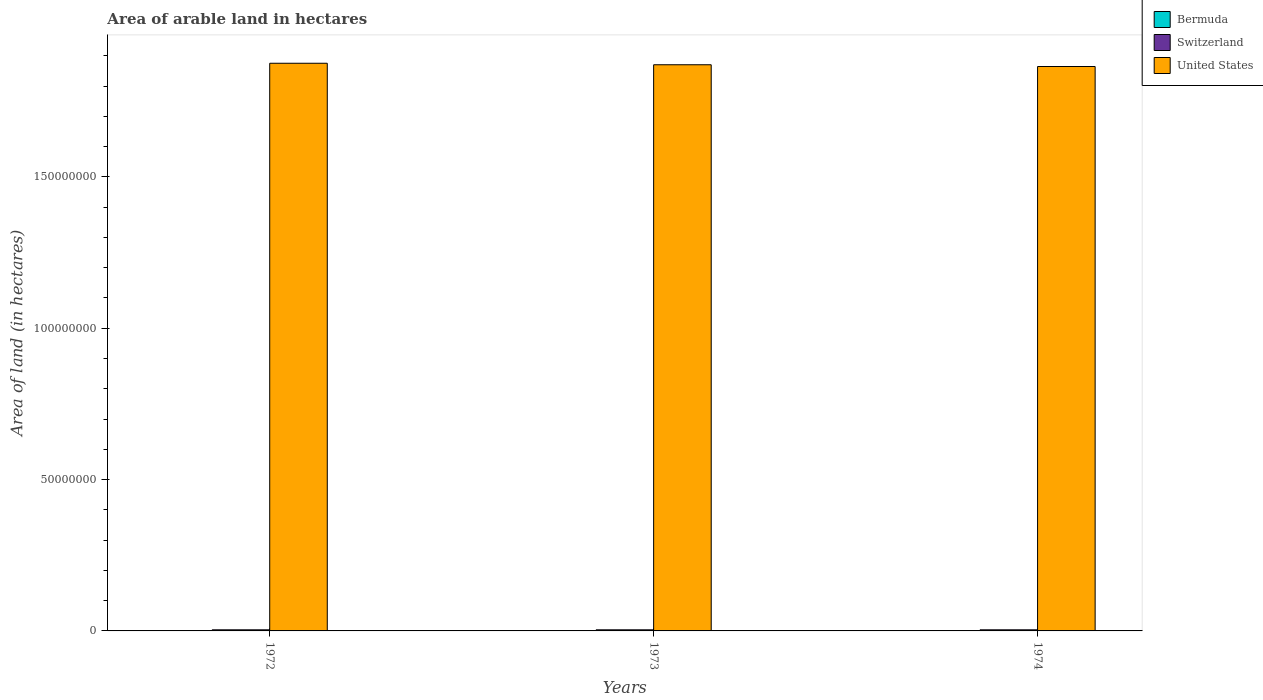How many groups of bars are there?
Provide a short and direct response. 3. Are the number of bars per tick equal to the number of legend labels?
Make the answer very short. Yes. Are the number of bars on each tick of the X-axis equal?
Give a very brief answer. Yes. How many bars are there on the 2nd tick from the right?
Offer a very short reply. 3. What is the label of the 2nd group of bars from the left?
Your answer should be very brief. 1973. In how many cases, is the number of bars for a given year not equal to the number of legend labels?
Offer a very short reply. 0. What is the total arable land in Switzerland in 1973?
Offer a very short reply. 3.63e+05. Across all years, what is the maximum total arable land in Bermuda?
Your response must be concise. 300. Across all years, what is the minimum total arable land in Switzerland?
Make the answer very short. 3.63e+05. In which year was the total arable land in Switzerland maximum?
Give a very brief answer. 1974. In which year was the total arable land in United States minimum?
Your answer should be compact. 1974. What is the total total arable land in Switzerland in the graph?
Keep it short and to the point. 1.09e+06. What is the difference between the total arable land in Bermuda in 1973 and the total arable land in United States in 1972?
Make the answer very short. -1.88e+08. What is the average total arable land in Switzerland per year?
Your answer should be compact. 3.64e+05. In the year 1972, what is the difference between the total arable land in Bermuda and total arable land in Switzerland?
Make the answer very short. -3.63e+05. In how many years, is the total arable land in United States greater than 80000000 hectares?
Provide a short and direct response. 3. What is the ratio of the total arable land in Switzerland in 1973 to that in 1974?
Provide a short and direct response. 0.99. Is the difference between the total arable land in Bermuda in 1972 and 1974 greater than the difference between the total arable land in Switzerland in 1972 and 1974?
Provide a succinct answer. Yes. What is the difference between the highest and the lowest total arable land in United States?
Your answer should be compact. 1.07e+06. What does the 2nd bar from the left in 1974 represents?
Give a very brief answer. Switzerland. What does the 1st bar from the right in 1972 represents?
Your answer should be compact. United States. How many bars are there?
Ensure brevity in your answer.  9. Are all the bars in the graph horizontal?
Your answer should be compact. No. Are the values on the major ticks of Y-axis written in scientific E-notation?
Your response must be concise. No. Does the graph contain any zero values?
Your answer should be very brief. No. Where does the legend appear in the graph?
Your answer should be very brief. Top right. How many legend labels are there?
Ensure brevity in your answer.  3. What is the title of the graph?
Offer a very short reply. Area of arable land in hectares. What is the label or title of the Y-axis?
Provide a succinct answer. Area of land (in hectares). What is the Area of land (in hectares) in Bermuda in 1972?
Ensure brevity in your answer.  300. What is the Area of land (in hectares) of Switzerland in 1972?
Provide a succinct answer. 3.63e+05. What is the Area of land (in hectares) of United States in 1972?
Keep it short and to the point. 1.88e+08. What is the Area of land (in hectares) of Bermuda in 1973?
Offer a terse response. 300. What is the Area of land (in hectares) of Switzerland in 1973?
Provide a succinct answer. 3.63e+05. What is the Area of land (in hectares) of United States in 1973?
Provide a short and direct response. 1.87e+08. What is the Area of land (in hectares) in Bermuda in 1974?
Ensure brevity in your answer.  300. What is the Area of land (in hectares) in Switzerland in 1974?
Keep it short and to the point. 3.65e+05. What is the Area of land (in hectares) of United States in 1974?
Keep it short and to the point. 1.86e+08. Across all years, what is the maximum Area of land (in hectares) in Bermuda?
Provide a succinct answer. 300. Across all years, what is the maximum Area of land (in hectares) of Switzerland?
Give a very brief answer. 3.65e+05. Across all years, what is the maximum Area of land (in hectares) in United States?
Keep it short and to the point. 1.88e+08. Across all years, what is the minimum Area of land (in hectares) in Bermuda?
Keep it short and to the point. 300. Across all years, what is the minimum Area of land (in hectares) in Switzerland?
Offer a terse response. 3.63e+05. Across all years, what is the minimum Area of land (in hectares) of United States?
Provide a succinct answer. 1.86e+08. What is the total Area of land (in hectares) of Bermuda in the graph?
Make the answer very short. 900. What is the total Area of land (in hectares) in Switzerland in the graph?
Ensure brevity in your answer.  1.09e+06. What is the total Area of land (in hectares) in United States in the graph?
Offer a terse response. 5.61e+08. What is the difference between the Area of land (in hectares) of Switzerland in 1972 and that in 1973?
Provide a succinct answer. 200. What is the difference between the Area of land (in hectares) of United States in 1972 and that in 1973?
Your answer should be compact. 4.95e+05. What is the difference between the Area of land (in hectares) in Switzerland in 1972 and that in 1974?
Provide a succinct answer. -2400. What is the difference between the Area of land (in hectares) of United States in 1972 and that in 1974?
Provide a short and direct response. 1.07e+06. What is the difference between the Area of land (in hectares) in Switzerland in 1973 and that in 1974?
Keep it short and to the point. -2600. What is the difference between the Area of land (in hectares) in United States in 1973 and that in 1974?
Give a very brief answer. 5.78e+05. What is the difference between the Area of land (in hectares) in Bermuda in 1972 and the Area of land (in hectares) in Switzerland in 1973?
Give a very brief answer. -3.62e+05. What is the difference between the Area of land (in hectares) of Bermuda in 1972 and the Area of land (in hectares) of United States in 1973?
Offer a very short reply. -1.87e+08. What is the difference between the Area of land (in hectares) of Switzerland in 1972 and the Area of land (in hectares) of United States in 1973?
Provide a succinct answer. -1.87e+08. What is the difference between the Area of land (in hectares) of Bermuda in 1972 and the Area of land (in hectares) of Switzerland in 1974?
Offer a terse response. -3.65e+05. What is the difference between the Area of land (in hectares) in Bermuda in 1972 and the Area of land (in hectares) in United States in 1974?
Keep it short and to the point. -1.86e+08. What is the difference between the Area of land (in hectares) of Switzerland in 1972 and the Area of land (in hectares) of United States in 1974?
Keep it short and to the point. -1.86e+08. What is the difference between the Area of land (in hectares) of Bermuda in 1973 and the Area of land (in hectares) of Switzerland in 1974?
Your response must be concise. -3.65e+05. What is the difference between the Area of land (in hectares) in Bermuda in 1973 and the Area of land (in hectares) in United States in 1974?
Offer a terse response. -1.86e+08. What is the difference between the Area of land (in hectares) of Switzerland in 1973 and the Area of land (in hectares) of United States in 1974?
Ensure brevity in your answer.  -1.86e+08. What is the average Area of land (in hectares) of Bermuda per year?
Your answer should be very brief. 300. What is the average Area of land (in hectares) in Switzerland per year?
Ensure brevity in your answer.  3.64e+05. What is the average Area of land (in hectares) in United States per year?
Your answer should be very brief. 1.87e+08. In the year 1972, what is the difference between the Area of land (in hectares) of Bermuda and Area of land (in hectares) of Switzerland?
Ensure brevity in your answer.  -3.63e+05. In the year 1972, what is the difference between the Area of land (in hectares) of Bermuda and Area of land (in hectares) of United States?
Make the answer very short. -1.88e+08. In the year 1972, what is the difference between the Area of land (in hectares) of Switzerland and Area of land (in hectares) of United States?
Give a very brief answer. -1.87e+08. In the year 1973, what is the difference between the Area of land (in hectares) of Bermuda and Area of land (in hectares) of Switzerland?
Provide a succinct answer. -3.62e+05. In the year 1973, what is the difference between the Area of land (in hectares) in Bermuda and Area of land (in hectares) in United States?
Offer a very short reply. -1.87e+08. In the year 1973, what is the difference between the Area of land (in hectares) in Switzerland and Area of land (in hectares) in United States?
Offer a very short reply. -1.87e+08. In the year 1974, what is the difference between the Area of land (in hectares) in Bermuda and Area of land (in hectares) in Switzerland?
Make the answer very short. -3.65e+05. In the year 1974, what is the difference between the Area of land (in hectares) of Bermuda and Area of land (in hectares) of United States?
Provide a short and direct response. -1.86e+08. In the year 1974, what is the difference between the Area of land (in hectares) in Switzerland and Area of land (in hectares) in United States?
Provide a succinct answer. -1.86e+08. What is the ratio of the Area of land (in hectares) in United States in 1972 to that in 1973?
Keep it short and to the point. 1. What is the ratio of the Area of land (in hectares) of Bermuda in 1973 to that in 1974?
Your answer should be very brief. 1. What is the difference between the highest and the second highest Area of land (in hectares) in Bermuda?
Ensure brevity in your answer.  0. What is the difference between the highest and the second highest Area of land (in hectares) of Switzerland?
Offer a very short reply. 2400. What is the difference between the highest and the second highest Area of land (in hectares) of United States?
Ensure brevity in your answer.  4.95e+05. What is the difference between the highest and the lowest Area of land (in hectares) of Bermuda?
Provide a succinct answer. 0. What is the difference between the highest and the lowest Area of land (in hectares) in Switzerland?
Your response must be concise. 2600. What is the difference between the highest and the lowest Area of land (in hectares) in United States?
Provide a succinct answer. 1.07e+06. 